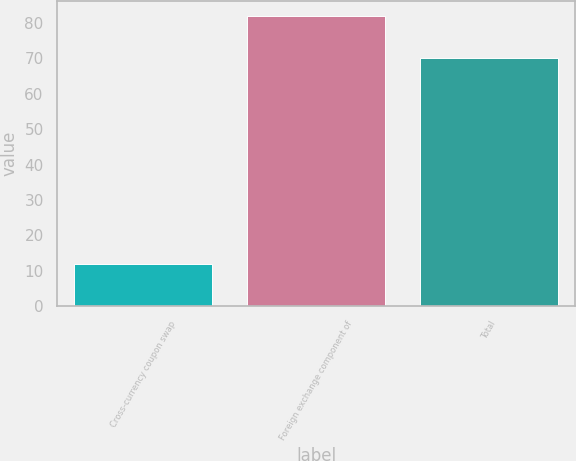<chart> <loc_0><loc_0><loc_500><loc_500><bar_chart><fcel>Cross-currency coupon swap<fcel>Foreign exchange component of<fcel>Total<nl><fcel>12<fcel>82<fcel>70<nl></chart> 